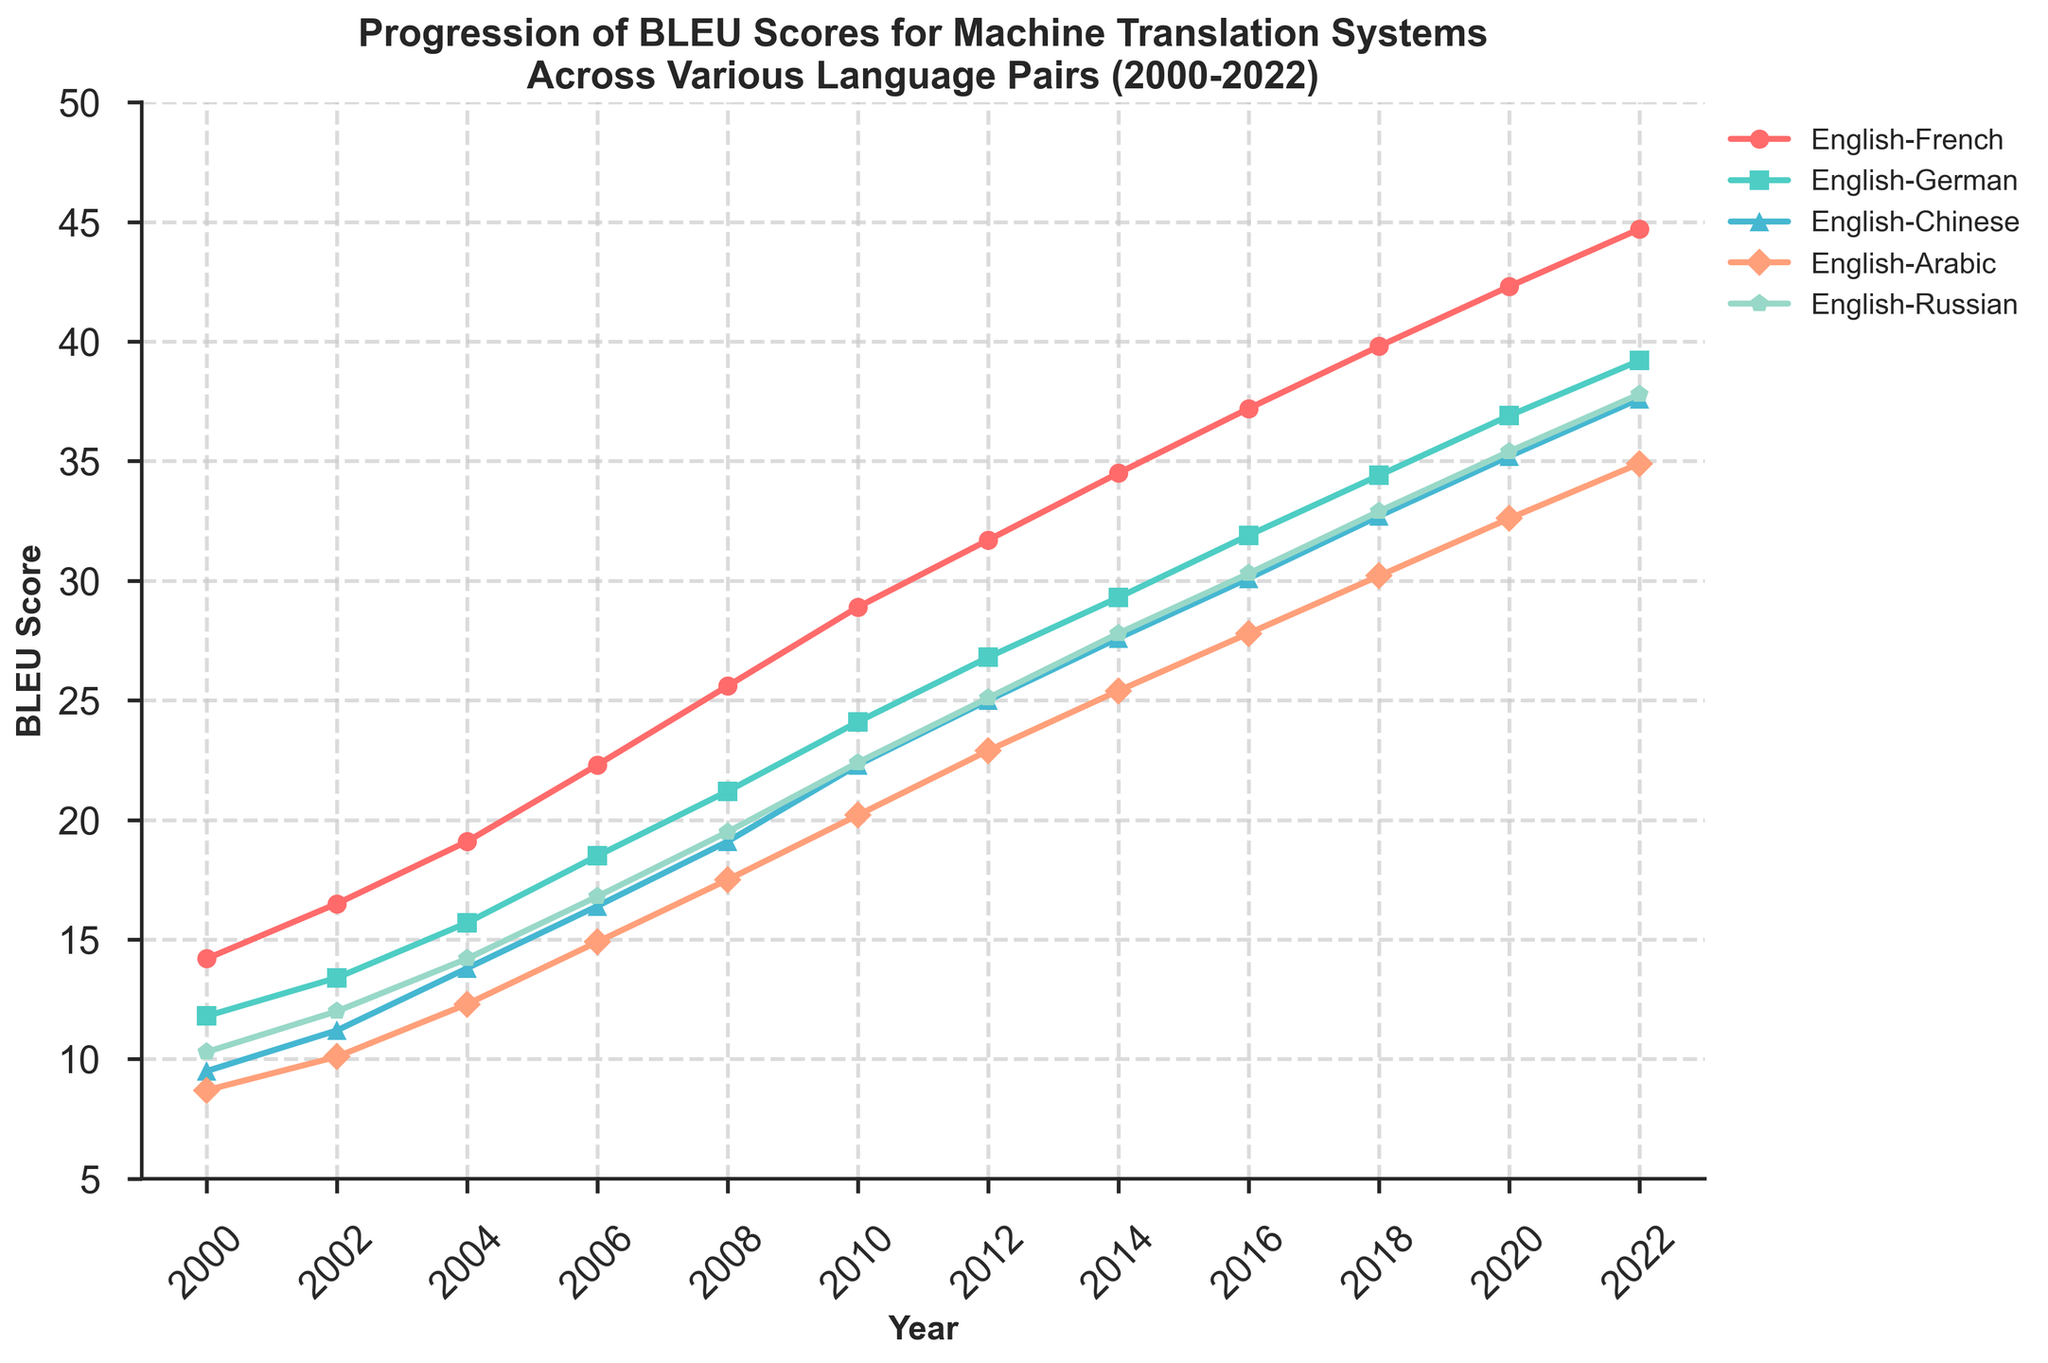What was the BLEU score for English-Russian translation in 2014? Locate the point corresponding to the year 2014 on the x-axis. Follow it upwards to the line representing English-Russian, which is marked by a specific color and marker. The y-axis value at this point indicates the BLEU score.
Answer: 27.8 Which language pair had the highest BLEU score in 2008? Check the values corresponding to each language pair in the year 2008. English-French has the highest value among them.
Answer: English-French Between which consecutive years did English-Chinese see the largest increase in BLEU score? Calculate the difference in BLEU scores for each pair of consecutive years for English-Chinese. The largest difference occurs between 2008 and 2010.
Answer: 2008-2010 How many language pairs had a BLEU score of at least 30 in the year 2018? Look at the BLEU scores for each language pair in the year 2018. Count how many are 30 or higher.
Answer: 3 Was the progression of BLEU scores for English-Arabic consistently increasing every year? Follow the trend line for English-Arabic across the years. Note if the line continuously rises without any decreases.
Answer: Yes What's the average BLEU score for English-German translation from 2000 to 2022? Sum the BLEU scores for English-German from each year: 11.8 + 13.4 + 15.7 + 18.5 + 21.2 + 24.1 + 26.8 + 29.3 + 31.9 + 34.4 + 36.9 + 39.2 = 302.2. Then divide by the number of years, which is 12.
Answer: 25.2 In which year did the BLEU score for English-Chinese first exceed 25? Identify the year when the BLEU score for English-Chinese first reaches or surpasses 25 by following the English-Chinese line and checking values against the y-axis.
Answer: 2012 By how much did the BLEU score for English-French increase from 2000 to 2022? Subtract the BLEU score for English-French in 2000 from its value in 2022: 44.7 - 14.2.
Answer: 30.5 Which language pair had the smallest increase in BLEU score from 2000 to 2022? Calculate the increase for each language pair by subtracting their 2000 score from their 2022 score. The smallest increase is for English-Russian: 37.8 - 10.3.
Answer: English-Russian What year marked the steepest gradient change for English-Arabic? Look for the year where the English-Arabic BLEU score line shows the steepest increase between two consecutive years. This is determined by the largest single-year change. The steepest gradient occurs between 2008 and 2010.
Answer: 2010 